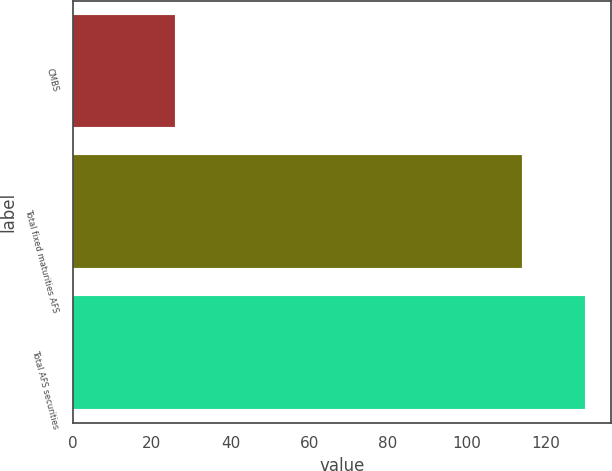Convert chart to OTSL. <chart><loc_0><loc_0><loc_500><loc_500><bar_chart><fcel>CMBS<fcel>Total fixed maturities AFS<fcel>Total AFS securities<nl><fcel>26<fcel>114<fcel>130<nl></chart> 